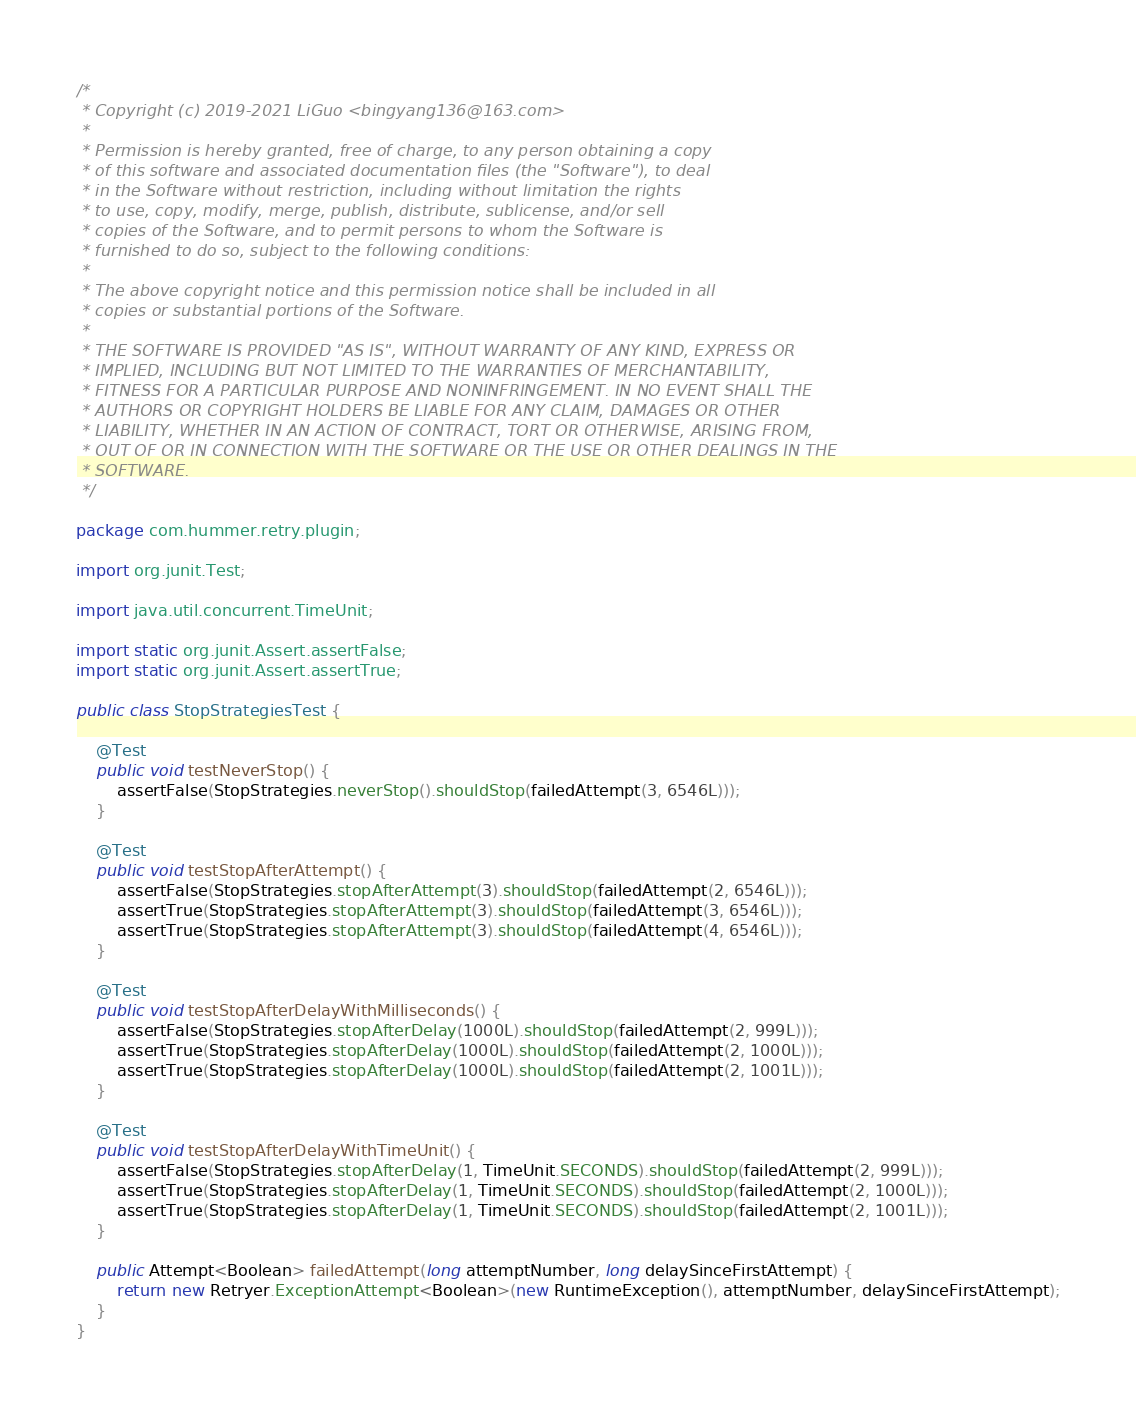<code> <loc_0><loc_0><loc_500><loc_500><_Java_>/*
 * Copyright (c) 2019-2021 LiGuo <bingyang136@163.com>
 *
 * Permission is hereby granted, free of charge, to any person obtaining a copy
 * of this software and associated documentation files (the "Software"), to deal
 * in the Software without restriction, including without limitation the rights
 * to use, copy, modify, merge, publish, distribute, sublicense, and/or sell
 * copies of the Software, and to permit persons to whom the Software is
 * furnished to do so, subject to the following conditions:
 *
 * The above copyright notice and this permission notice shall be included in all
 * copies or substantial portions of the Software.
 *
 * THE SOFTWARE IS PROVIDED "AS IS", WITHOUT WARRANTY OF ANY KIND, EXPRESS OR
 * IMPLIED, INCLUDING BUT NOT LIMITED TO THE WARRANTIES OF MERCHANTABILITY,
 * FITNESS FOR A PARTICULAR PURPOSE AND NONINFRINGEMENT. IN NO EVENT SHALL THE
 * AUTHORS OR COPYRIGHT HOLDERS BE LIABLE FOR ANY CLAIM, DAMAGES OR OTHER
 * LIABILITY, WHETHER IN AN ACTION OF CONTRACT, TORT OR OTHERWISE, ARISING FROM,
 * OUT OF OR IN CONNECTION WITH THE SOFTWARE OR THE USE OR OTHER DEALINGS IN THE
 * SOFTWARE.
 */

package com.hummer.retry.plugin;

import org.junit.Test;

import java.util.concurrent.TimeUnit;

import static org.junit.Assert.assertFalse;
import static org.junit.Assert.assertTrue;

public class StopStrategiesTest {

    @Test
    public void testNeverStop() {
        assertFalse(StopStrategies.neverStop().shouldStop(failedAttempt(3, 6546L)));
    }

    @Test
    public void testStopAfterAttempt() {
        assertFalse(StopStrategies.stopAfterAttempt(3).shouldStop(failedAttempt(2, 6546L)));
        assertTrue(StopStrategies.stopAfterAttempt(3).shouldStop(failedAttempt(3, 6546L)));
        assertTrue(StopStrategies.stopAfterAttempt(3).shouldStop(failedAttempt(4, 6546L)));
    }

    @Test
    public void testStopAfterDelayWithMilliseconds() {
        assertFalse(StopStrategies.stopAfterDelay(1000L).shouldStop(failedAttempt(2, 999L)));
        assertTrue(StopStrategies.stopAfterDelay(1000L).shouldStop(failedAttempt(2, 1000L)));
        assertTrue(StopStrategies.stopAfterDelay(1000L).shouldStop(failedAttempt(2, 1001L)));
    }

    @Test
    public void testStopAfterDelayWithTimeUnit() {
        assertFalse(StopStrategies.stopAfterDelay(1, TimeUnit.SECONDS).shouldStop(failedAttempt(2, 999L)));
        assertTrue(StopStrategies.stopAfterDelay(1, TimeUnit.SECONDS).shouldStop(failedAttempt(2, 1000L)));
        assertTrue(StopStrategies.stopAfterDelay(1, TimeUnit.SECONDS).shouldStop(failedAttempt(2, 1001L)));
    }

    public Attempt<Boolean> failedAttempt(long attemptNumber, long delaySinceFirstAttempt) {
        return new Retryer.ExceptionAttempt<Boolean>(new RuntimeException(), attemptNumber, delaySinceFirstAttempt);
    }
}
</code> 